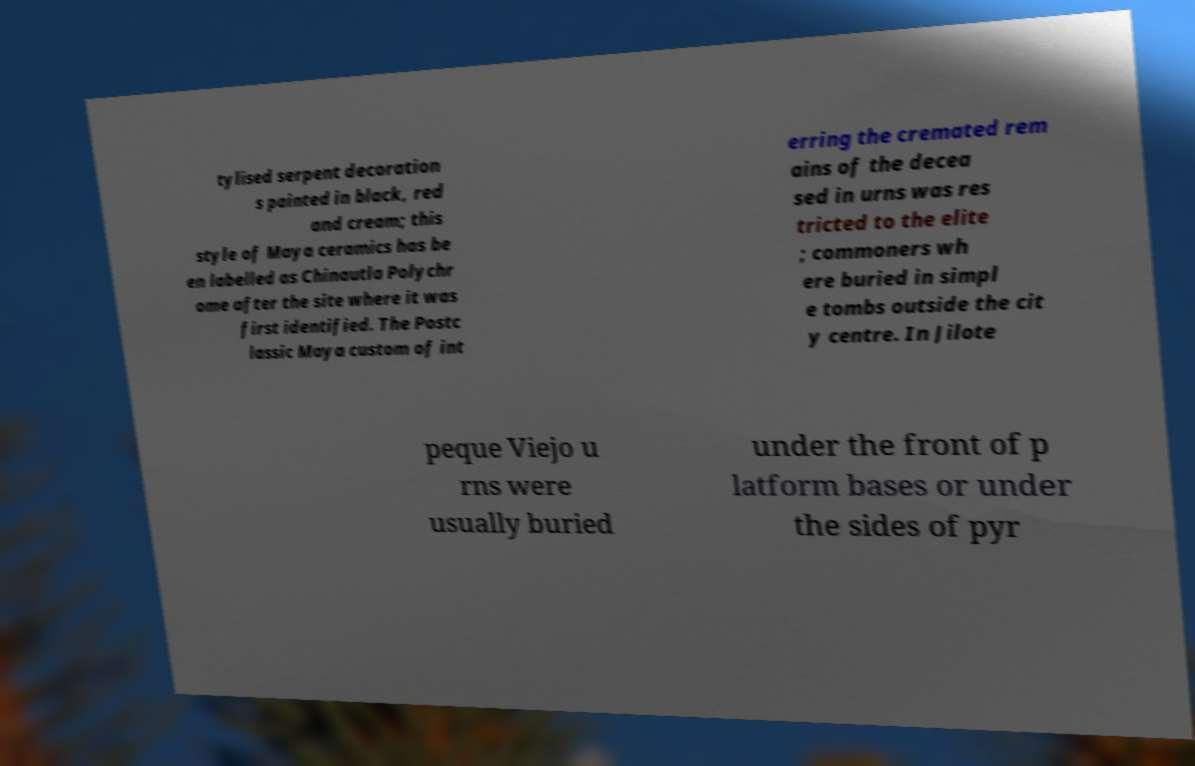Please read and relay the text visible in this image. What does it say? tylised serpent decoration s painted in black, red and cream; this style of Maya ceramics has be en labelled as Chinautla Polychr ome after the site where it was first identified. The Postc lassic Maya custom of int erring the cremated rem ains of the decea sed in urns was res tricted to the elite ; commoners wh ere buried in simpl e tombs outside the cit y centre. In Jilote peque Viejo u rns were usually buried under the front of p latform bases or under the sides of pyr 